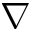Convert formula to latex. <formula><loc_0><loc_0><loc_500><loc_500>\nabla</formula> 